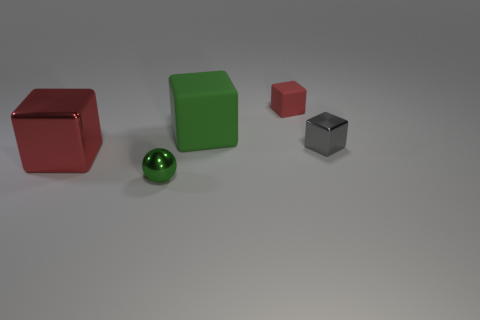Subtract all small red rubber cubes. How many cubes are left? 3 Subtract all gray cylinders. How many red cubes are left? 2 Add 2 tiny balls. How many objects exist? 7 Subtract all red blocks. How many blocks are left? 2 Subtract all cubes. How many objects are left? 1 Add 5 small objects. How many small objects are left? 8 Add 4 gray metal objects. How many gray metal objects exist? 5 Subtract 1 green cubes. How many objects are left? 4 Subtract all yellow blocks. Subtract all blue spheres. How many blocks are left? 4 Subtract all tiny yellow matte cubes. Subtract all red objects. How many objects are left? 3 